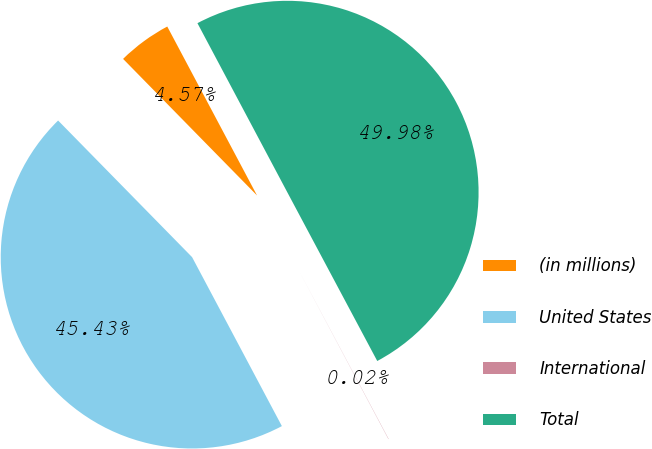Convert chart to OTSL. <chart><loc_0><loc_0><loc_500><loc_500><pie_chart><fcel>(in millions)<fcel>United States<fcel>International<fcel>Total<nl><fcel>4.57%<fcel>45.43%<fcel>0.02%<fcel>49.98%<nl></chart> 